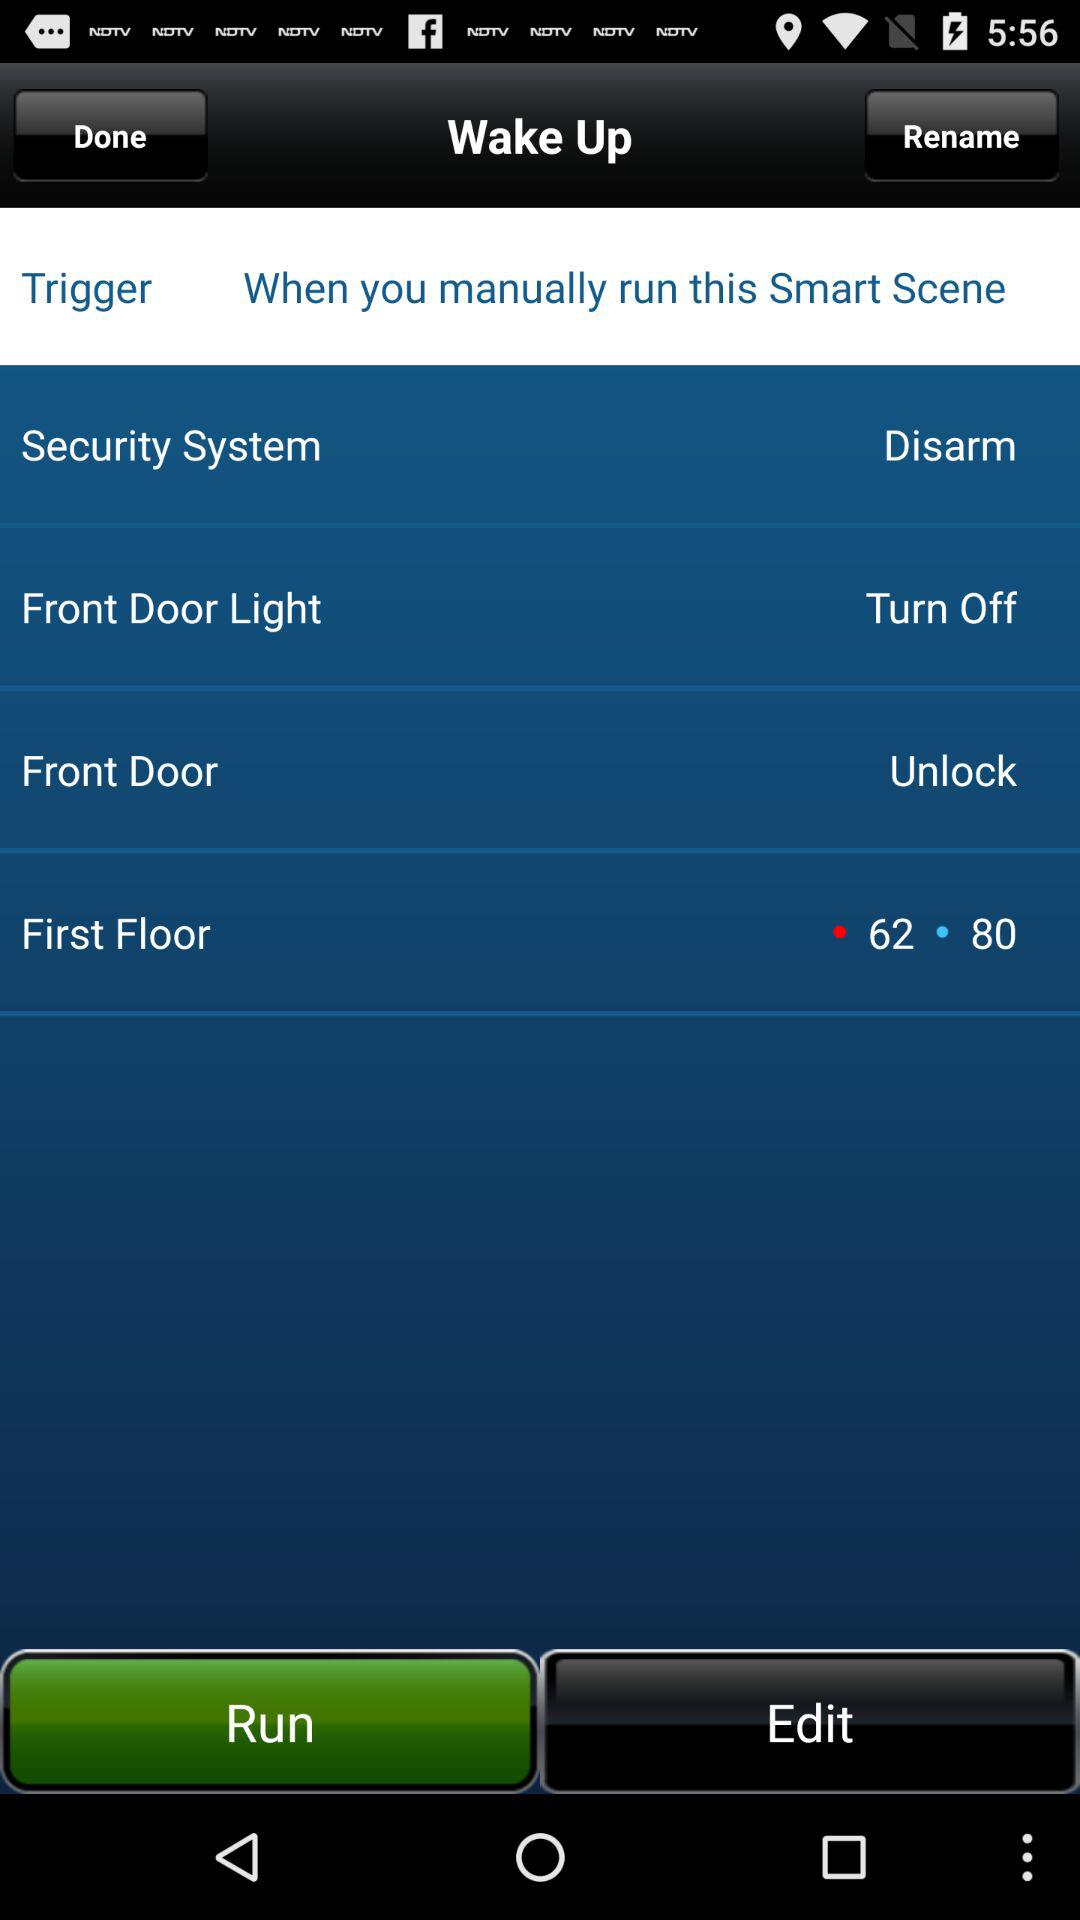What is the status of "Front Door Light"? The status is "Turn Off". 